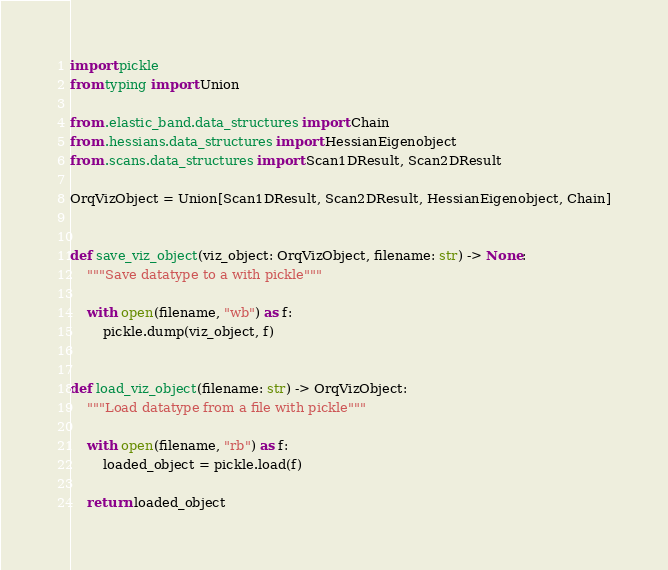Convert code to text. <code><loc_0><loc_0><loc_500><loc_500><_Python_>import pickle
from typing import Union

from .elastic_band.data_structures import Chain
from .hessians.data_structures import HessianEigenobject
from .scans.data_structures import Scan1DResult, Scan2DResult

OrqVizObject = Union[Scan1DResult, Scan2DResult, HessianEigenobject, Chain]


def save_viz_object(viz_object: OrqVizObject, filename: str) -> None:
    """Save datatype to a with pickle"""

    with open(filename, "wb") as f:
        pickle.dump(viz_object, f)


def load_viz_object(filename: str) -> OrqVizObject:
    """Load datatype from a file with pickle"""

    with open(filename, "rb") as f:
        loaded_object = pickle.load(f)

    return loaded_object
</code> 